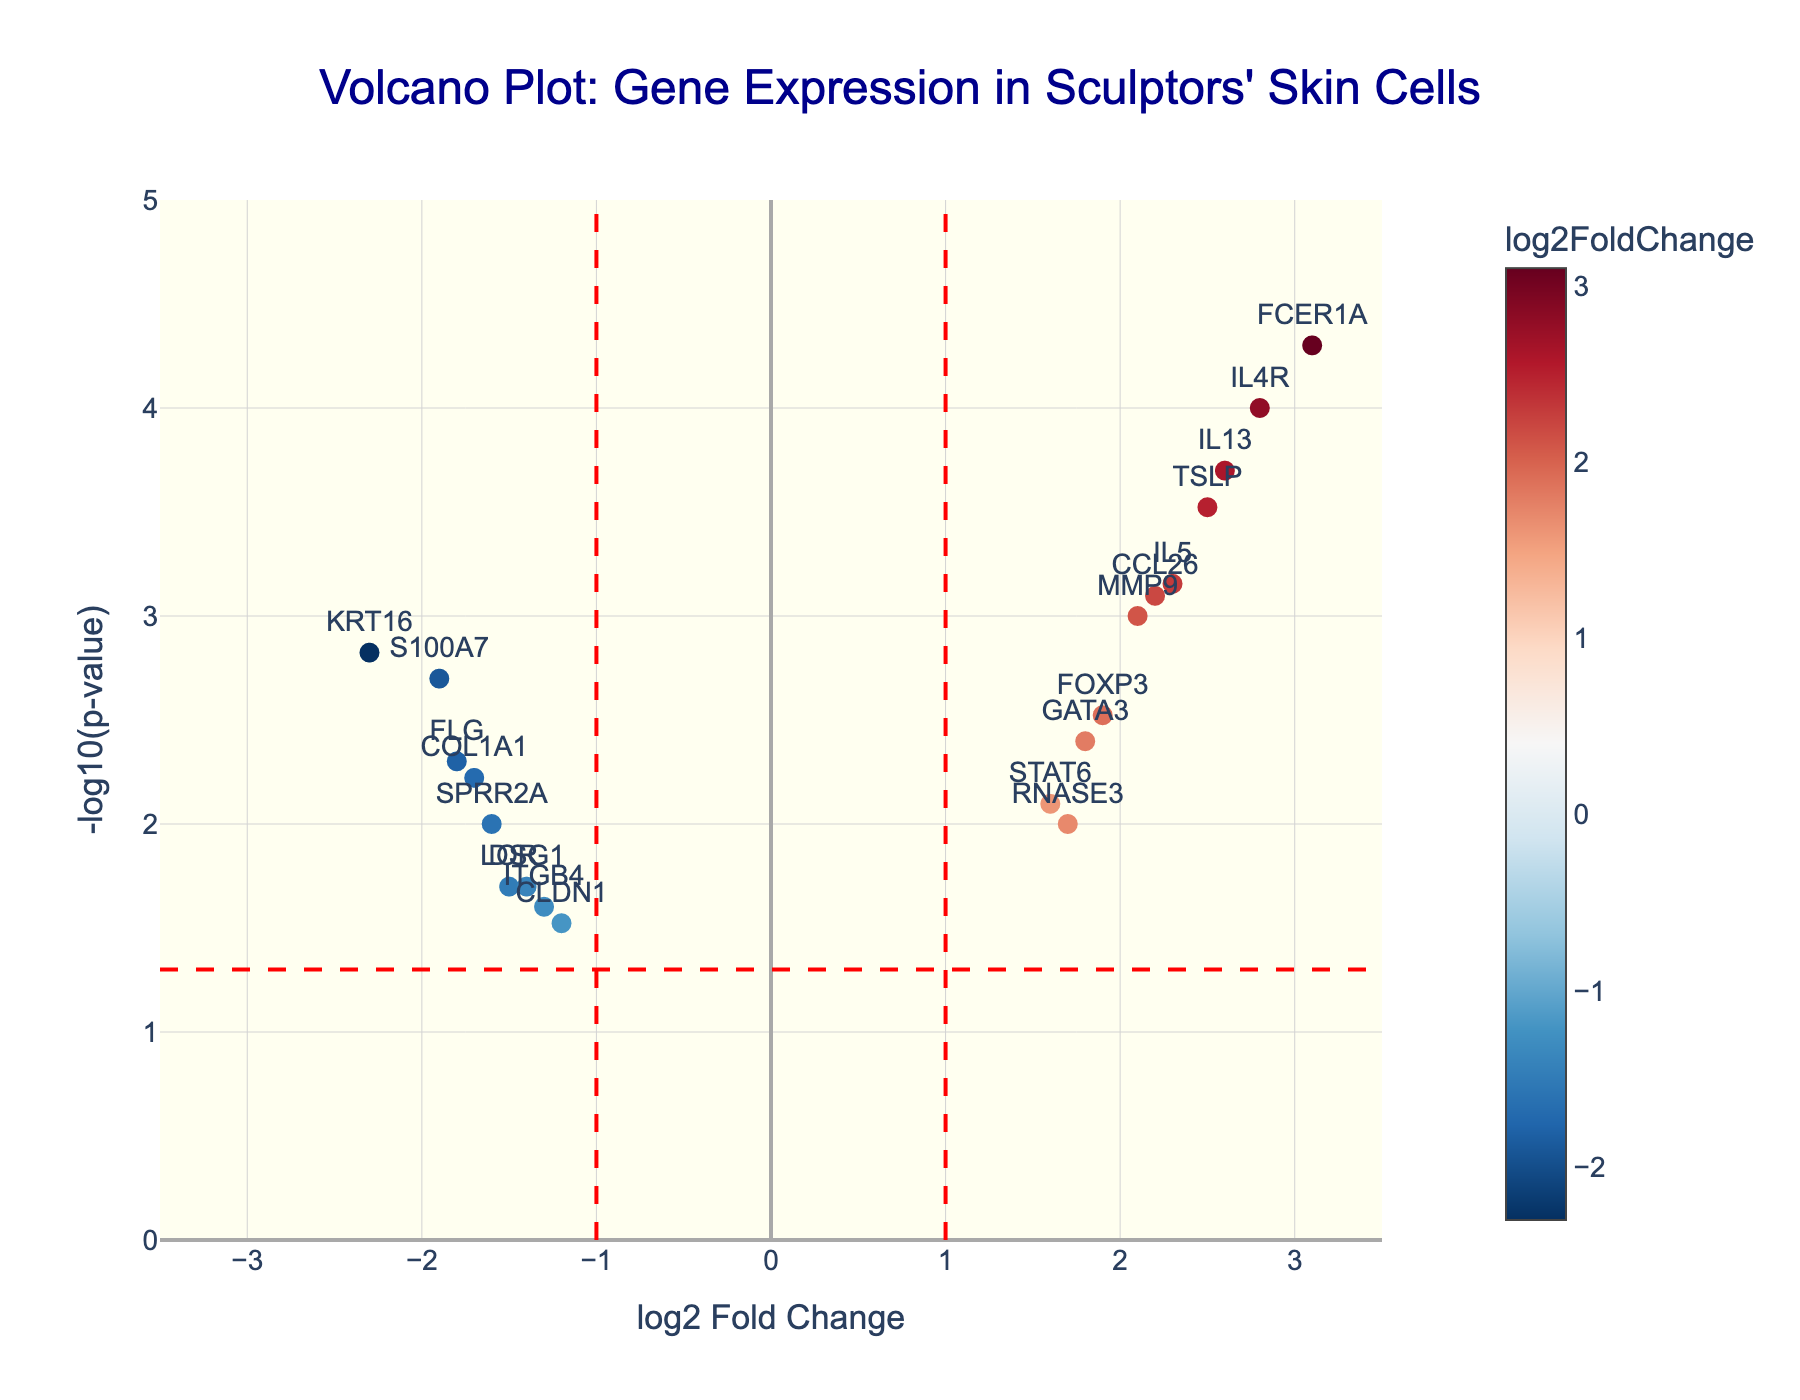What is the title of the plot? The title of a plot is typically displayed at the top and summarizes the content or purpose of the figure. In this case, it reads "Volcano Plot: Gene Expression in Sculptors' Skin Cells."
Answer: "Volcano Plot: Gene Expression in Sculptors' Skin Cells" What are the axes labels and ranges in the plot? The x-axis label is "log2 Fold Change," and it ranges from -3.5 to 3.5. The y-axis label is "-log10(p-value)," and it ranges from 0 to 5.
Answer: x-axis: "log2 Fold Change" (-3.5 to 3.5), y-axis: "-log10(p-value)" (0 to 5) How many genes are depicted in the plot? By counting the individual data points, which represent different genes, the total number of genes can be determined. In this plot, 20 genes are shown.
Answer: 20 Which gene has the highest log2 fold change? The gene with the highest log2 fold change can be identified by finding the data point furthest to the right on the x-axis. It is FCER1A with a log2 fold change of 3.1.
Answer: FCER1A Which gene has the lowest p-value? The gene with the lowest p-value can be identified by locating the point highest on the y-axis, as p-value is transformed to -log10(p-value). FCER1A has the lowest p-value of 0.00005.
Answer: FCER1A Are there more significantly upregulated or downregulated genes based on the provided plot? Significantly upregulated genes are marked by positive log2 fold changes greater than 1 and less than -log10(p-value). Downregulated ones have negative log2 fold changes smaller than -1 in the same p-value condition. Counting them gives us 8 upregulated and 7 downregulated significant genes.
Answer: More significantly upregulated genes Which genes fall below the significance threshold of p-value 0.05? By looking at the horizontal red line representing the p-value threshold at -log10(0.05) and noting which points lie above it, we identify IL4R, FCER1A, TSLP, CCL26, IL13, IL5, and MMP9.
Answer: IL4R, FCER1A, TSLP, CCL26, IL13, IL5, MMP9 What is the theory behind a volcano plot? A volcano plot is used to display the statistical significance versus magnitude of change in gene expression. It combines a measure of statistical significance from a statistical test (P-value) with the magnitude of the fold change, allowing for quicker interpretation of large datasets.
Answer: Displays statistical significance vs. magnitude of change in gene expression Which gene has a similar p-value but an opposite log2 fold change compared to FLG? By comparing the points that align vertically with FLG’s position on the y-axis but are on the opposite side of 0 in the x-axis, we find that IL5 has a similar p-value but an opposite log2 fold change (FLG: -1.8; IL5: 2.3).
Answer: IL5 